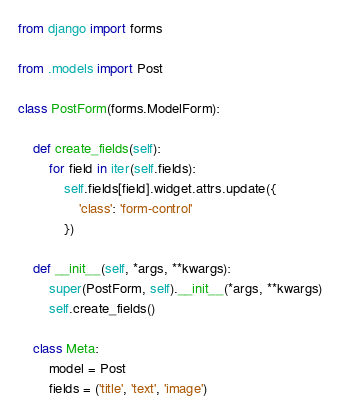Convert code to text. <code><loc_0><loc_0><loc_500><loc_500><_Python_>from django import forms

from .models import Post

class PostForm(forms.ModelForm):

    def create_fields(self):
        for field in iter(self.fields):
            self.fields[field].widget.attrs.update({
                'class': 'form-control'
            })
            
    def __init__(self, *args, **kwargs):
        super(PostForm, self).__init__(*args, **kwargs)
        self.create_fields()

    class Meta:
        model = Post
        fields = ('title', 'text', 'image')</code> 